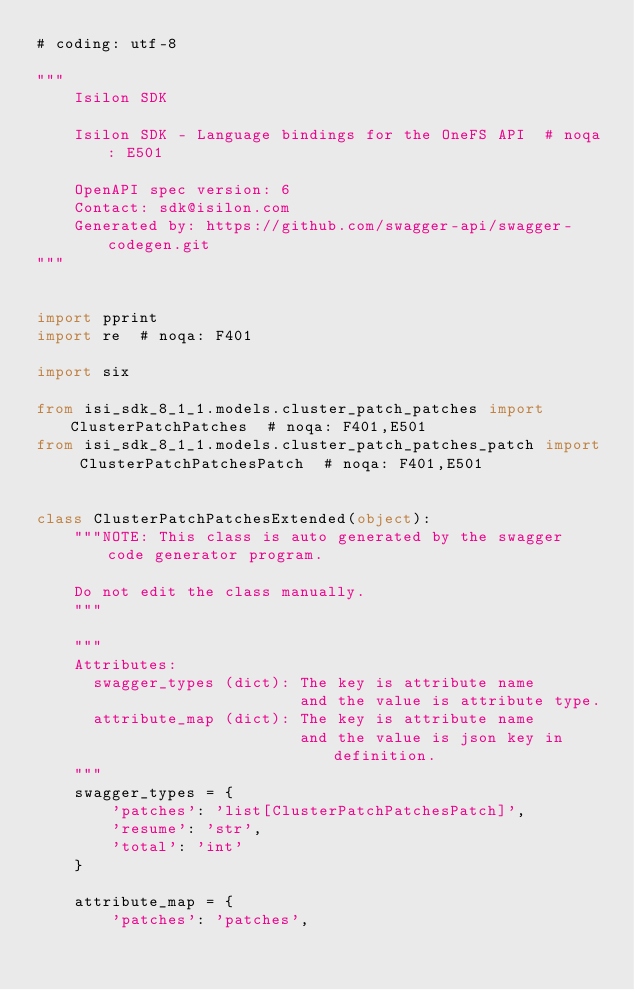<code> <loc_0><loc_0><loc_500><loc_500><_Python_># coding: utf-8

"""
    Isilon SDK

    Isilon SDK - Language bindings for the OneFS API  # noqa: E501

    OpenAPI spec version: 6
    Contact: sdk@isilon.com
    Generated by: https://github.com/swagger-api/swagger-codegen.git
"""


import pprint
import re  # noqa: F401

import six

from isi_sdk_8_1_1.models.cluster_patch_patches import ClusterPatchPatches  # noqa: F401,E501
from isi_sdk_8_1_1.models.cluster_patch_patches_patch import ClusterPatchPatchesPatch  # noqa: F401,E501


class ClusterPatchPatchesExtended(object):
    """NOTE: This class is auto generated by the swagger code generator program.

    Do not edit the class manually.
    """

    """
    Attributes:
      swagger_types (dict): The key is attribute name
                            and the value is attribute type.
      attribute_map (dict): The key is attribute name
                            and the value is json key in definition.
    """
    swagger_types = {
        'patches': 'list[ClusterPatchPatchesPatch]',
        'resume': 'str',
        'total': 'int'
    }

    attribute_map = {
        'patches': 'patches',</code> 